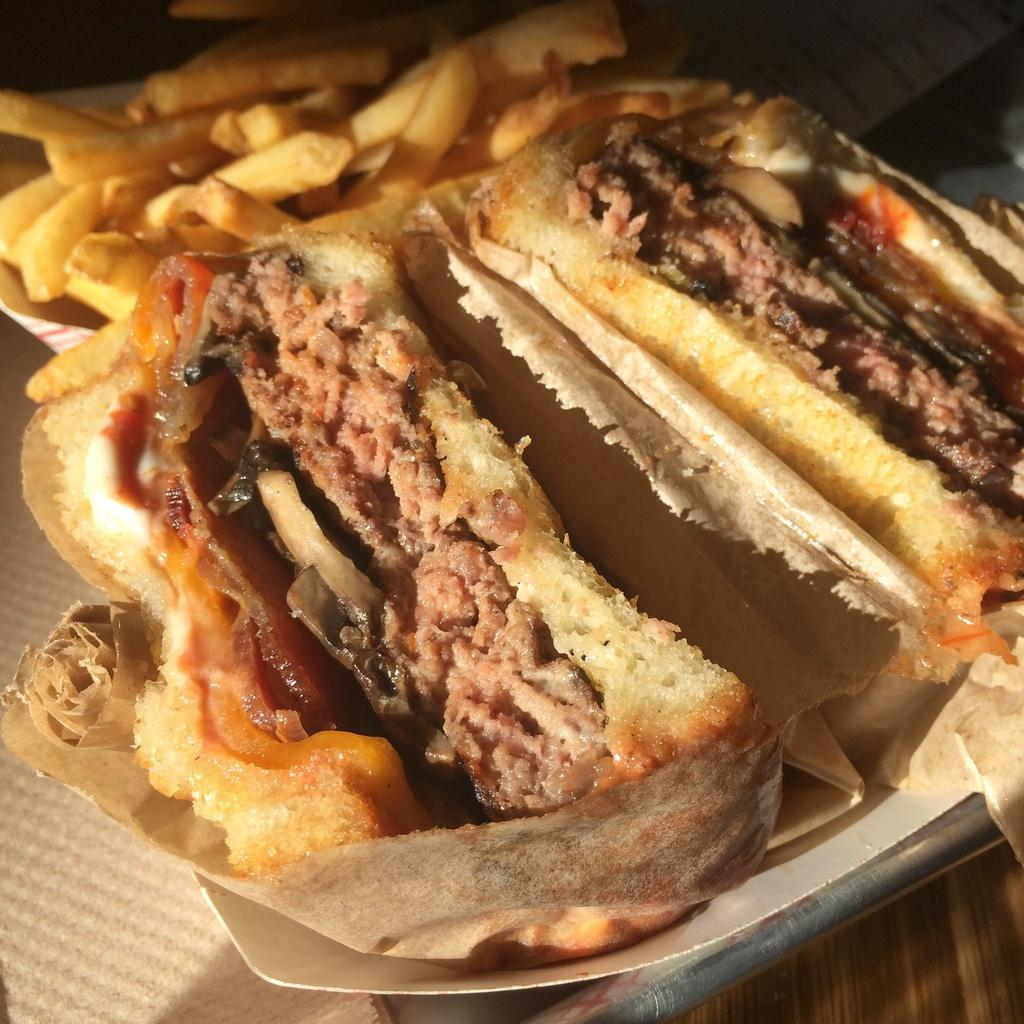What type of food can be seen on a plate in the image? There are sandwiches on a plate in the image. What type of food is in a paper bowl on the table in the image? There are french fries in a paper bowl on the table in the image. Can you see a cat licking its tongue in the image? There is no cat or tongue present in the image. Is there a cub playing with the sandwiches in the image? There is no cub or any animal present in the image; it only features sandwiches and french fries. 